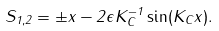Convert formula to latex. <formula><loc_0><loc_0><loc_500><loc_500>S _ { 1 , 2 } = \pm x - 2 \epsilon K _ { C } ^ { - 1 } \sin ( K _ { C } x ) .</formula> 